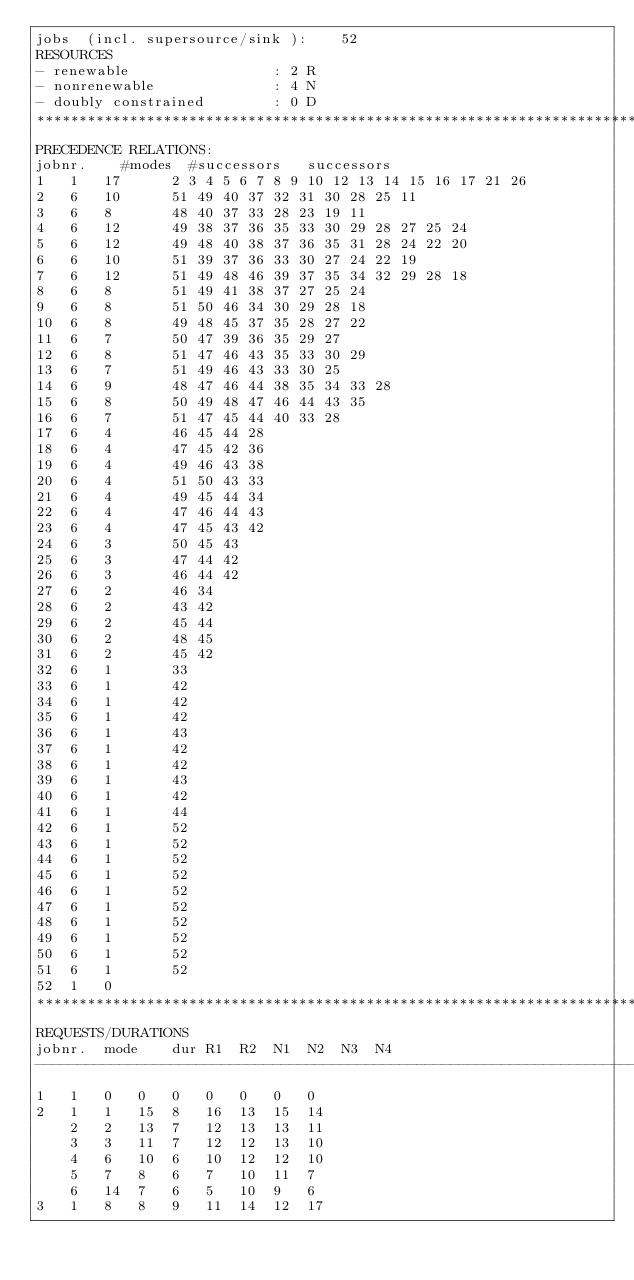Convert code to text. <code><loc_0><loc_0><loc_500><loc_500><_ObjectiveC_>jobs  (incl. supersource/sink ):	52
RESOURCES
- renewable                 : 2 R
- nonrenewable              : 4 N
- doubly constrained        : 0 D
************************************************************************
PRECEDENCE RELATIONS:
jobnr.    #modes  #successors   successors
1	1	17		2 3 4 5 6 7 8 9 10 12 13 14 15 16 17 21 26 
2	6	10		51 49 40 37 32 31 30 28 25 11 
3	6	8		48 40 37 33 28 23 19 11 
4	6	12		49 38 37 36 35 33 30 29 28 27 25 24 
5	6	12		49 48 40 38 37 36 35 31 28 24 22 20 
6	6	10		51 39 37 36 33 30 27 24 22 19 
7	6	12		51 49 48 46 39 37 35 34 32 29 28 18 
8	6	8		51 49 41 38 37 27 25 24 
9	6	8		51 50 46 34 30 29 28 18 
10	6	8		49 48 45 37 35 28 27 22 
11	6	7		50 47 39 36 35 29 27 
12	6	8		51 47 46 43 35 33 30 29 
13	6	7		51 49 46 43 33 30 25 
14	6	9		48 47 46 44 38 35 34 33 28 
15	6	8		50 49 48 47 46 44 43 35 
16	6	7		51 47 45 44 40 33 28 
17	6	4		46 45 44 28 
18	6	4		47 45 42 36 
19	6	4		49 46 43 38 
20	6	4		51 50 43 33 
21	6	4		49 45 44 34 
22	6	4		47 46 44 43 
23	6	4		47 45 43 42 
24	6	3		50 45 43 
25	6	3		47 44 42 
26	6	3		46 44 42 
27	6	2		46 34 
28	6	2		43 42 
29	6	2		45 44 
30	6	2		48 45 
31	6	2		45 42 
32	6	1		33 
33	6	1		42 
34	6	1		42 
35	6	1		42 
36	6	1		43 
37	6	1		42 
38	6	1		42 
39	6	1		43 
40	6	1		42 
41	6	1		44 
42	6	1		52 
43	6	1		52 
44	6	1		52 
45	6	1		52 
46	6	1		52 
47	6	1		52 
48	6	1		52 
49	6	1		52 
50	6	1		52 
51	6	1		52 
52	1	0		
************************************************************************
REQUESTS/DURATIONS
jobnr.	mode	dur	R1	R2	N1	N2	N3	N4	
------------------------------------------------------------------------
1	1	0	0	0	0	0	0	0	
2	1	1	15	8	16	13	15	14	
	2	2	13	7	12	13	13	11	
	3	3	11	7	12	12	13	10	
	4	6	10	6	10	12	12	10	
	5	7	8	6	7	10	11	7	
	6	14	7	6	5	10	9	6	
3	1	8	8	9	11	14	12	17	</code> 